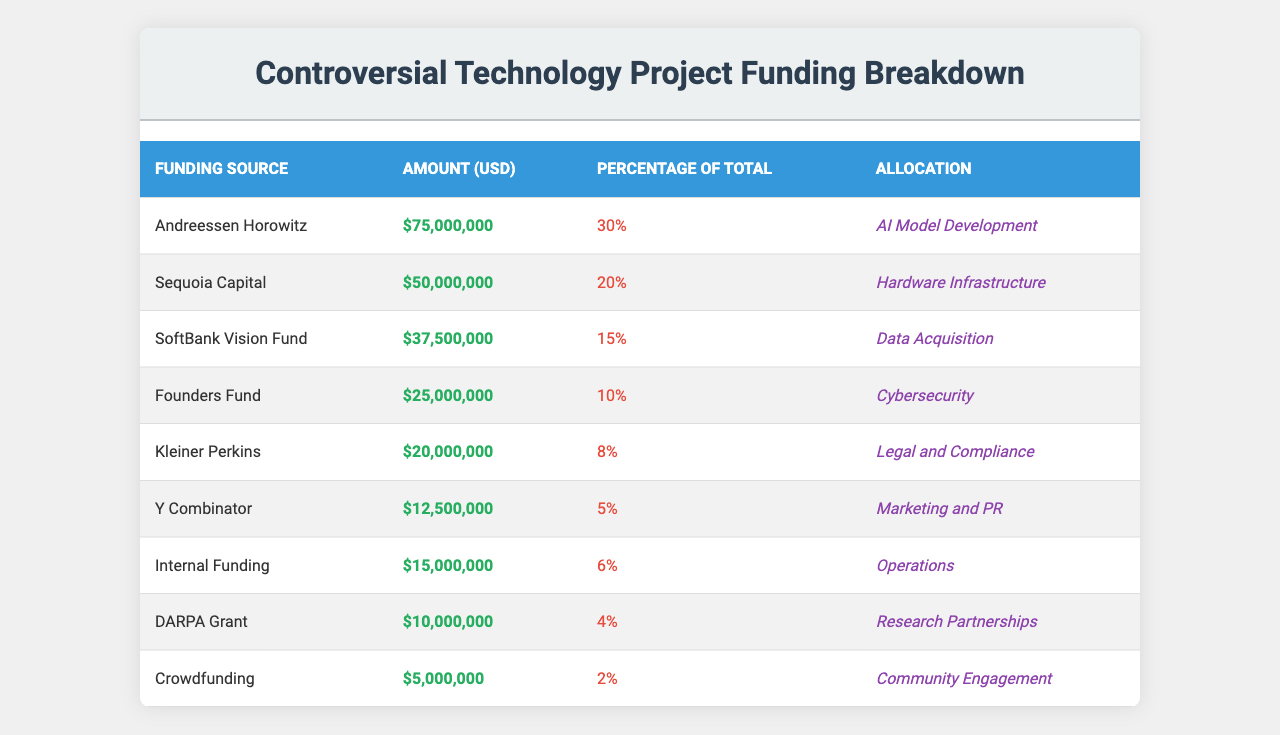What is the total amount of funding for the project? To find the total funding, we need to sum all the amounts in the Amount column. The amounts are 75,000,000 + 50,000,000 + 37,500,000 + 25,000,000 + 20,000,000 + 12,500,000 + 15,000,000 + 10,000,000 + 5,000,000, which equals 250,000,000.
Answer: 250,000,000 Which funding source contributed the least amount? To determine the least contribution, we examine the Amount column and see that Crowdfunding contributed 5,000,000, which is less than all other amounts listed.
Answer: Crowdfunding What percentage of total funding is allocated to AI Model Development? The funding allocated to AI Model Development is 75,000,000. The total funding is 250,000,000, so the percentage is (75,000,000 / 250,000,000) * 100 = 30%.
Answer: 30% How much more funding did Andreessen Horowitz contribute compared to Y Combinator? Andreessen Horowitz contributed 75,000,000 while Y Combinator contributed 12,500,000. The difference is 75,000,000 - 12,500,000 = 62,500,000.
Answer: 62,500,000 Is the amount from SoftBank Vision Fund greater than the sum of amounts from Founders Fund and Kleiner Perkins? Adding the amounts from Founders Fund, which is 25,000,000 and Kleiner Perkins, which is 20,000,000 gives us 45,000,000. SoftBank Vision Fund's contribution is 37,500,000, which is not greater than 45,000,000.
Answer: No What percentage of the total funding is allocated to marketing and PR, and how does it compare to the allocation for operations? Marketing and PR received 12,500,000, which is (12,500,000 / 250,000,000) * 100 = 5%. Operations received 15,000,000, which is (15,000,000 / 250,000,000) * 100 = 6%. Therefore, the allocation for operations is greater than that for marketing and PR.
Answer: Operations is greater What is the total percentage of funding allocated to the top three funding sources? The top three funding sources are Andreessen Horowitz (30%), Sequoia Capital (20%), and SoftBank Vision Fund (15%). Adding these percentages yields 30 + 20 + 15 = 65%.
Answer: 65% Which funding source has the highest percentage of total funding and what is its allocation? The funding source with the highest percentage is Andreessen Horowitz with 30% for AI Model Development.
Answer: Andreessen Horowitz, AI Model Development How much funding is allocated for research partnerships compared to community engagement? Research Partnerships received 10,000,000 and Community Engagement received 5,000,000. The difference is 10,000,000 - 5,000,000 = 5,000,000, meaning there is more funding for research partnerships.
Answer: 5,000,000 more for research partnerships If the amounts for DARPA Grant and Crowdfunding were combined, would they exceed the amount allocated to legal and compliance? DARPA Grant is 10,000,000 and Crowdfunding is 5,000,000, adding these gives 10,000,000 + 5,000,000 = 15,000,000. The amount allocated for Legal and Compliance is 20,000,000, which is greater.
Answer: No 